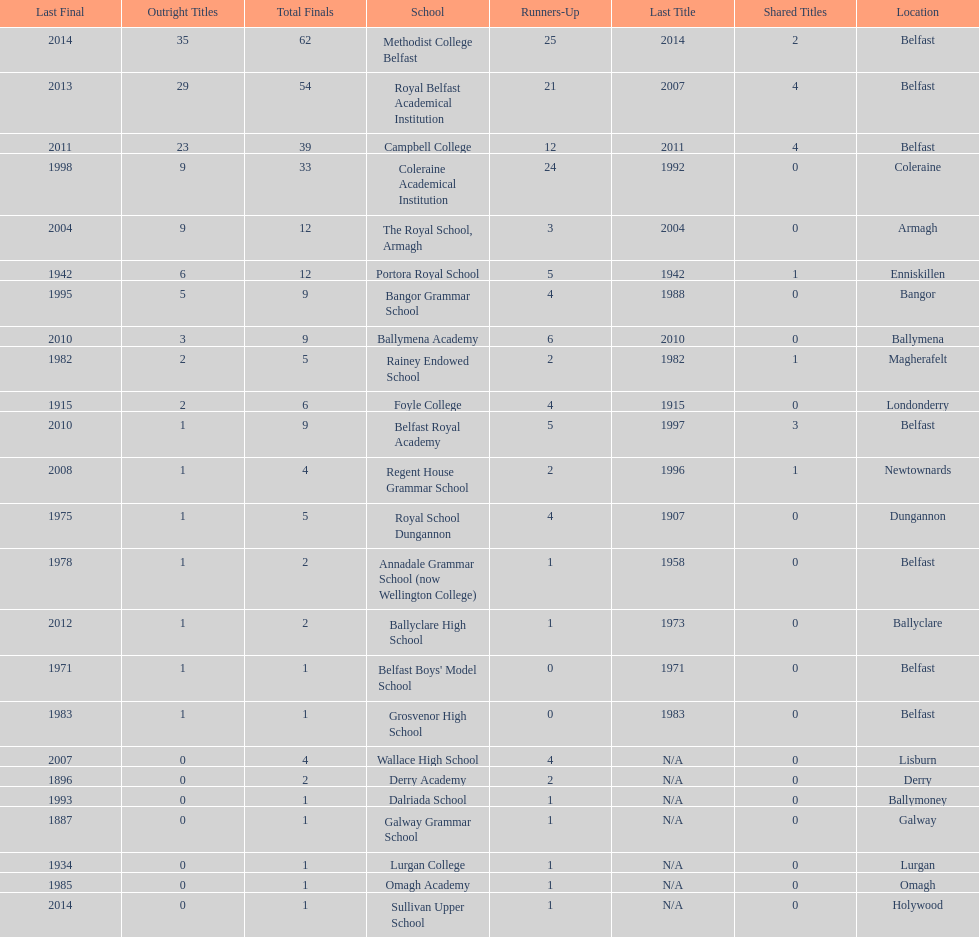How many outright titles does coleraine academical institution have? 9. What other school has this amount of outright titles The Royal School, Armagh. 